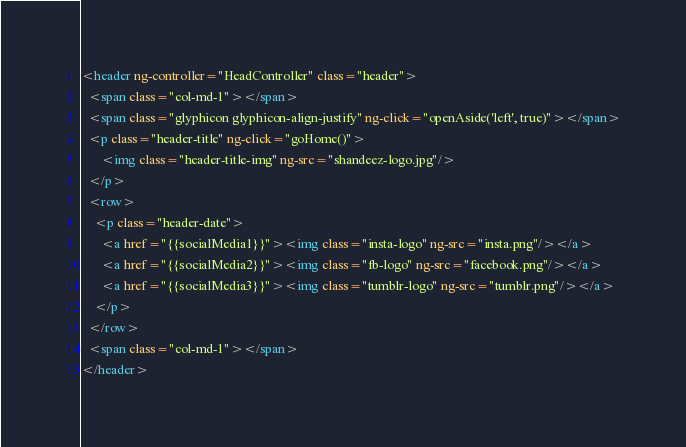Convert code to text. <code><loc_0><loc_0><loc_500><loc_500><_HTML_><header ng-controller="HeadController" class="header">
  <span class="col-md-1"></span>
  <span class="glyphicon glyphicon-align-justify" ng-click="openAside('left', true)"></span>
  <p class="header-title" ng-click="goHome()">
      <img class="header-title-img" ng-src="shandeez-logo.jpg"/>
  </p>
  <row>
    <p class="header-date">
      <a href="{{socialMedia1}}"><img class="insta-logo" ng-src="insta.png"/></a>
      <a href="{{socialMedia2}}"><img class="fb-logo" ng-src="facebook.png"/></a>
      <a href="{{socialMedia3}}"><img class="tumblr-logo" ng-src="tumblr.png"/></a>
    </p>
  </row>
  <span class="col-md-1"></span>
</header>
</code> 